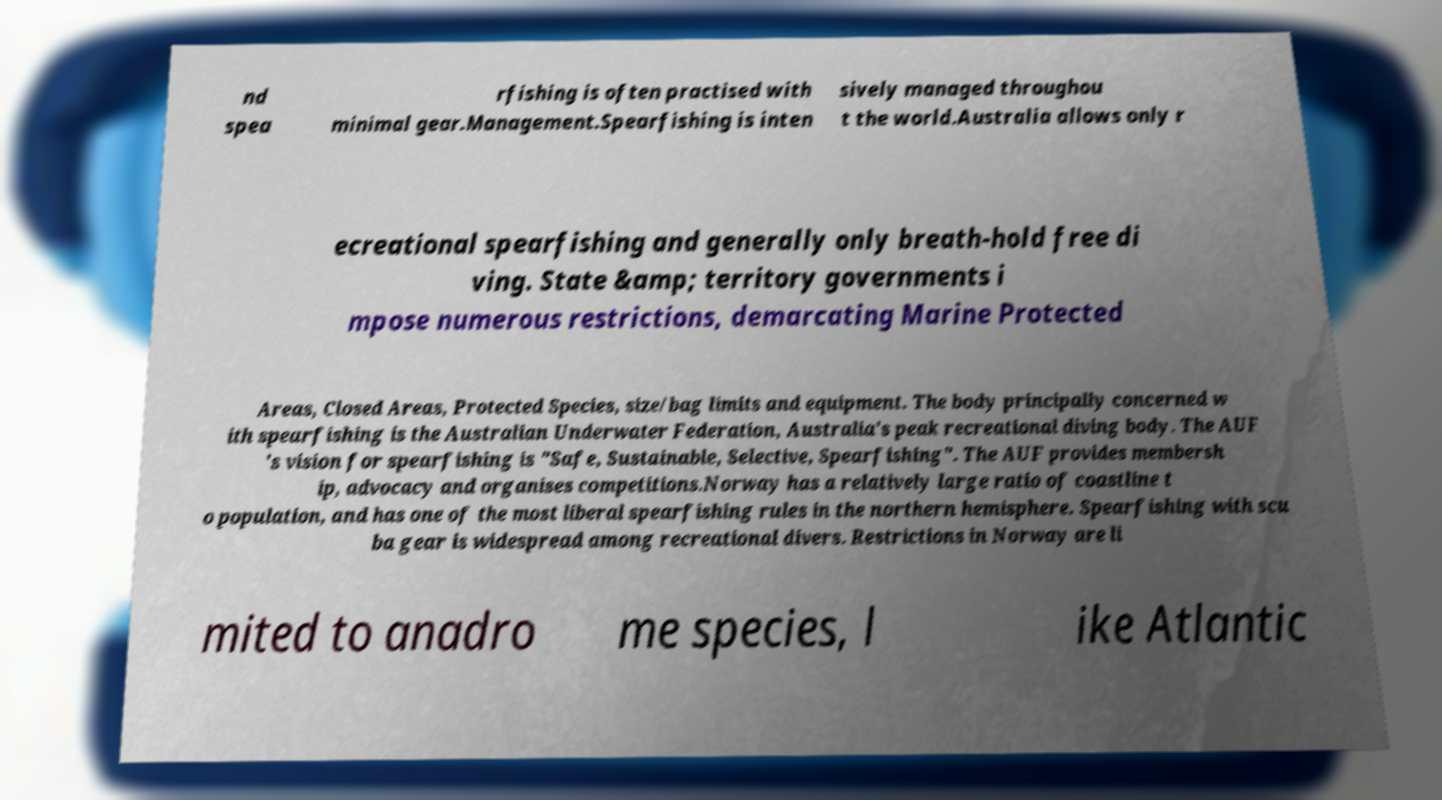Please identify and transcribe the text found in this image. nd spea rfishing is often practised with minimal gear.Management.Spearfishing is inten sively managed throughou t the world.Australia allows only r ecreational spearfishing and generally only breath-hold free di ving. State &amp; territory governments i mpose numerous restrictions, demarcating Marine Protected Areas, Closed Areas, Protected Species, size/bag limits and equipment. The body principally concerned w ith spearfishing is the Australian Underwater Federation, Australia's peak recreational diving body. The AUF 's vision for spearfishing is "Safe, Sustainable, Selective, Spearfishing". The AUF provides membersh ip, advocacy and organises competitions.Norway has a relatively large ratio of coastline t o population, and has one of the most liberal spearfishing rules in the northern hemisphere. Spearfishing with scu ba gear is widespread among recreational divers. Restrictions in Norway are li mited to anadro me species, l ike Atlantic 